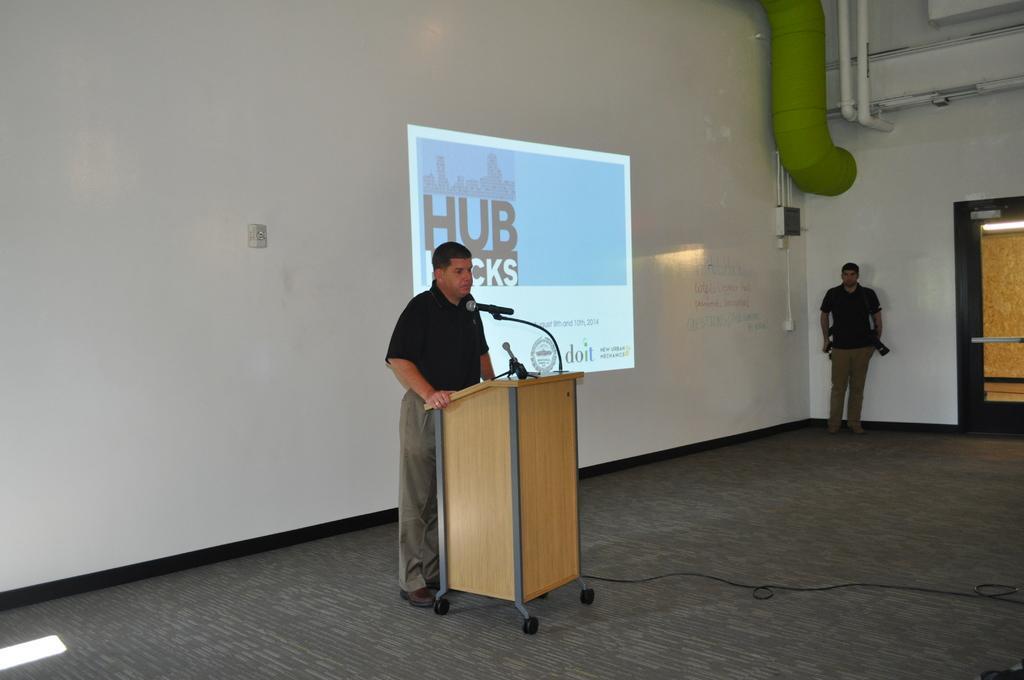How would you summarize this image in a sentence or two? As we can see in the image there is a white color wall, screen, door, mic and two persons wearing black color t shirts. 